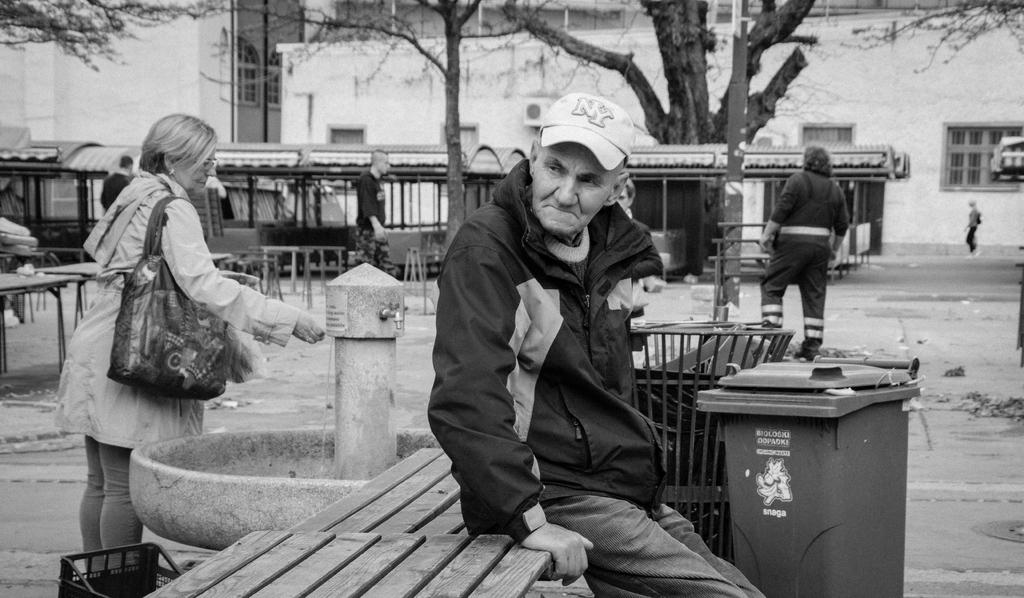<image>
Offer a succinct explanation of the picture presented. Man wearing a cap which says NY sitting on the bench. 